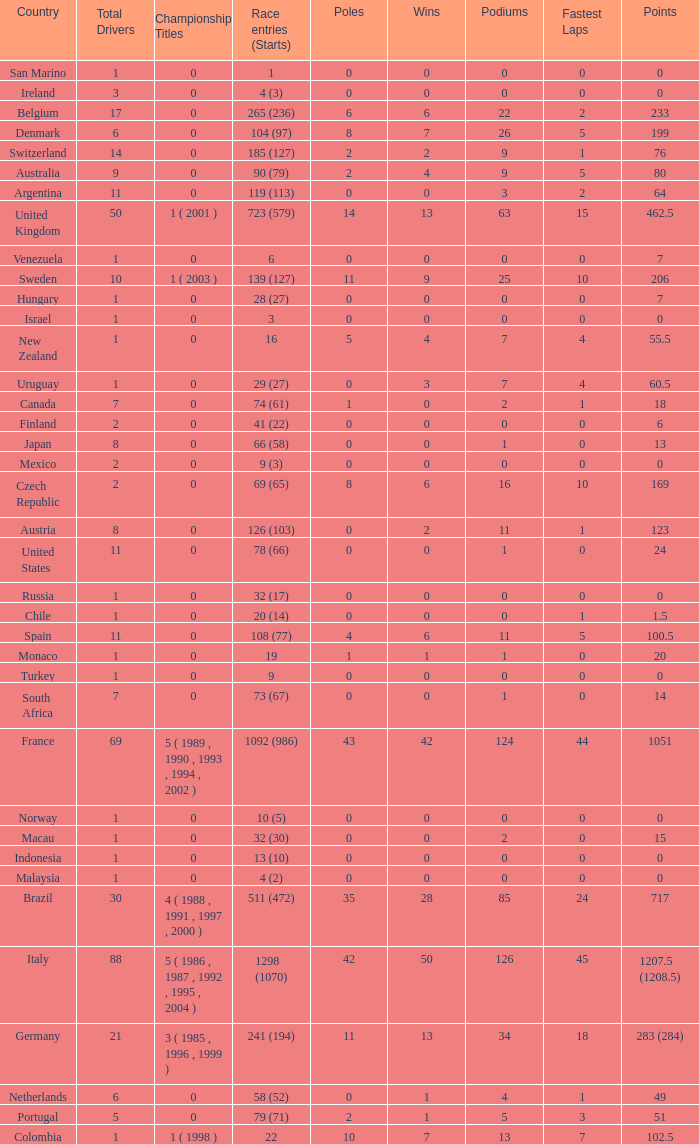How many titles for the nation with less than 3 fastest laps and 22 podiums? 0.0. 